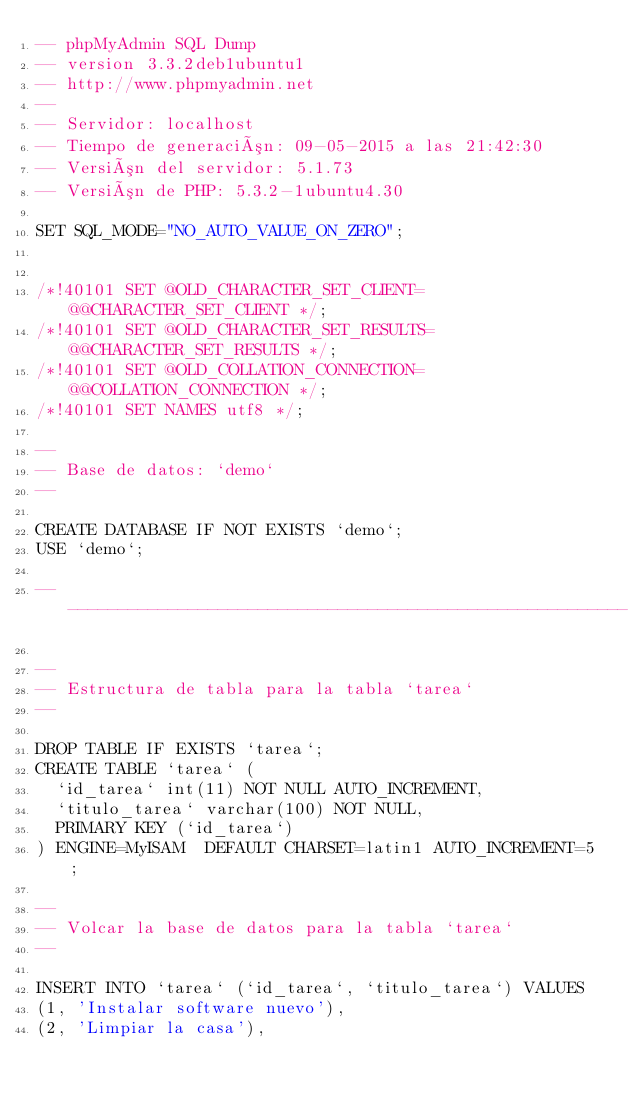<code> <loc_0><loc_0><loc_500><loc_500><_SQL_>-- phpMyAdmin SQL Dump
-- version 3.3.2deb1ubuntu1
-- http://www.phpmyadmin.net
--
-- Servidor: localhost
-- Tiempo de generación: 09-05-2015 a las 21:42:30
-- Versión del servidor: 5.1.73
-- Versión de PHP: 5.3.2-1ubuntu4.30

SET SQL_MODE="NO_AUTO_VALUE_ON_ZERO";


/*!40101 SET @OLD_CHARACTER_SET_CLIENT=@@CHARACTER_SET_CLIENT */;
/*!40101 SET @OLD_CHARACTER_SET_RESULTS=@@CHARACTER_SET_RESULTS */;
/*!40101 SET @OLD_COLLATION_CONNECTION=@@COLLATION_CONNECTION */;
/*!40101 SET NAMES utf8 */;

--
-- Base de datos: `demo`
--

CREATE DATABASE IF NOT EXISTS `demo`;
USE `demo`;

-- --------------------------------------------------------

--
-- Estructura de tabla para la tabla `tarea`
--

DROP TABLE IF EXISTS `tarea`;
CREATE TABLE `tarea` (
  `id_tarea` int(11) NOT NULL AUTO_INCREMENT,
  `titulo_tarea` varchar(100) NOT NULL,
  PRIMARY KEY (`id_tarea`)
) ENGINE=MyISAM  DEFAULT CHARSET=latin1 AUTO_INCREMENT=5 ;

--
-- Volcar la base de datos para la tabla `tarea`
--

INSERT INTO `tarea` (`id_tarea`, `titulo_tarea`) VALUES
(1, 'Instalar software nuevo'),
(2, 'Limpiar la casa'),</code> 